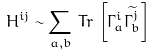<formula> <loc_0><loc_0><loc_500><loc_500>H ^ { i j } \sim \sum _ { a , b } \, T r \, \left [ \Gamma _ { a } ^ { i } \widetilde { \Gamma _ { b } ^ { j } } \right ]</formula> 